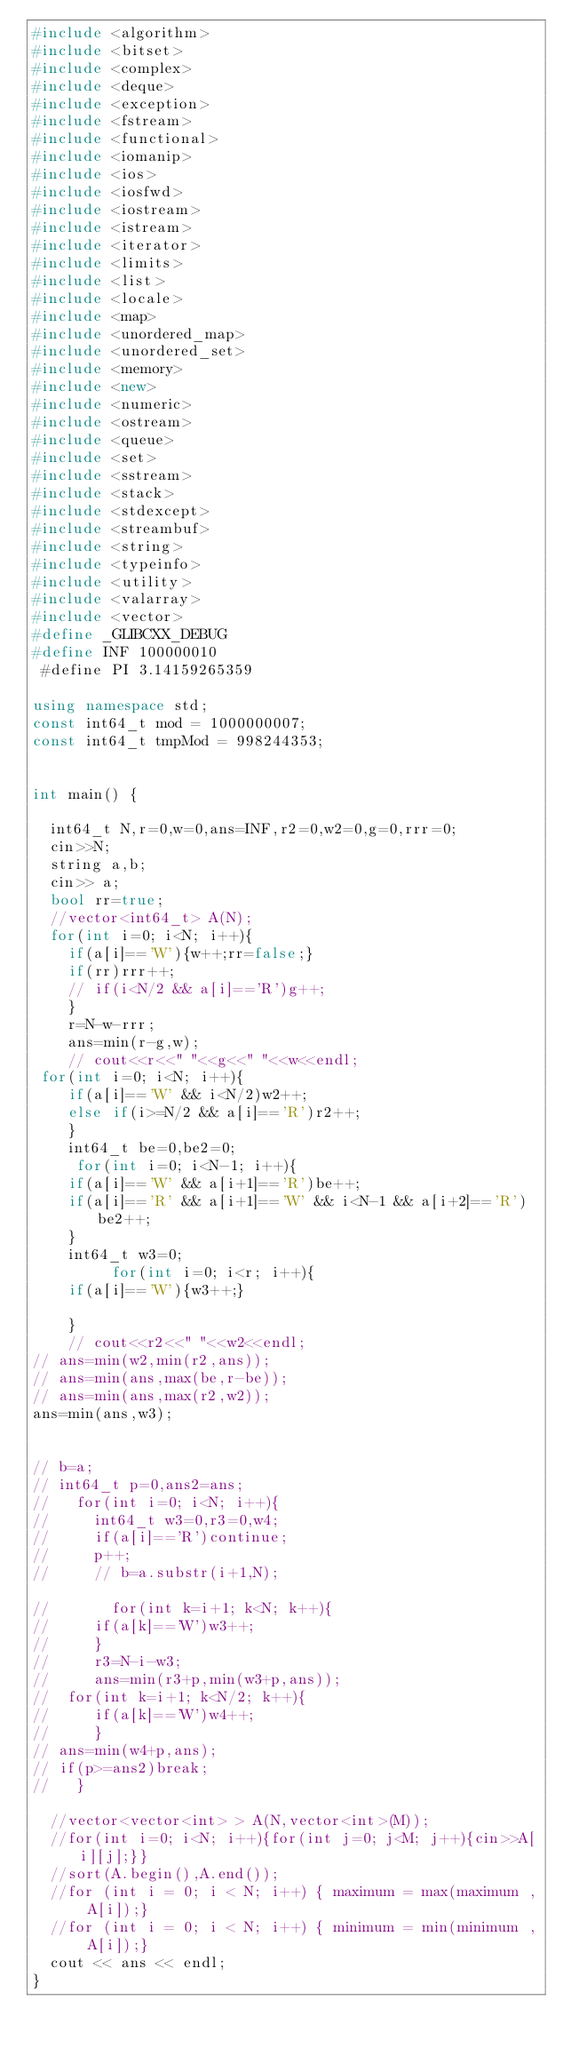Convert code to text. <code><loc_0><loc_0><loc_500><loc_500><_C++_>#include <algorithm>
#include <bitset>
#include <complex>
#include <deque>
#include <exception>
#include <fstream>
#include <functional>
#include <iomanip>
#include <ios>
#include <iosfwd>
#include <iostream>
#include <istream>
#include <iterator>
#include <limits>
#include <list>
#include <locale>
#include <map>
#include <unordered_map>
#include <unordered_set>
#include <memory>
#include <new>
#include <numeric>
#include <ostream>
#include <queue>
#include <set>
#include <sstream>
#include <stack>
#include <stdexcept>
#include <streambuf>
#include <string>
#include <typeinfo>
#include <utility>
#include <valarray>
#include <vector>
#define _GLIBCXX_DEBUG
#define INF 100000010
 #define PI 3.14159265359

using namespace std;
const int64_t mod = 1000000007;
const int64_t tmpMod = 998244353;


int main() {
 
  int64_t N,r=0,w=0,ans=INF,r2=0,w2=0,g=0,rrr=0;
  cin>>N;
  string a,b;
  cin>> a;
  bool rr=true;
  //vector<int64_t> A(N);
  for(int i=0; i<N; i++){
    if(a[i]=='W'){w++;rr=false;}
    if(rr)rrr++;
    // if(i<N/2 && a[i]=='R')g++;
    }
    r=N-w-rrr;
    ans=min(r-g,w);
    // cout<<r<<" "<<g<<" "<<w<<endl;
 for(int i=0; i<N; i++){
    if(a[i]=='W' && i<N/2)w2++;
    else if(i>=N/2 && a[i]=='R')r2++;
    }
    int64_t be=0,be2=0;
     for(int i=0; i<N-1; i++){
    if(a[i]=='W' && a[i+1]=='R')be++;
    if(a[i]=='R' && a[i+1]=='W' && i<N-1 && a[i+2]=='R')be2++;
    }
    int64_t w3=0;
         for(int i=0; i<r; i++){
    if(a[i]=='W'){w3++;}
    
    }
    // cout<<r2<<" "<<w2<<endl;
// ans=min(w2,min(r2,ans));
// ans=min(ans,max(be,r-be));
// ans=min(ans,max(r2,w2));
ans=min(ans,w3);


// b=a;
// int64_t p=0,ans2=ans;
//   for(int i=0; i<N; i++){
//     int64_t w3=0,r3=0,w4;
//     if(a[i]=='R')continue;
//     p++;
//     // b=a.substr(i+1,N);

//       for(int k=i+1; k<N; k++){
//     if(a[k]=='W')w3++;
//     }
//     r3=N-i-w3;
//     ans=min(r3+p,min(w3+p,ans));
//  for(int k=i+1; k<N/2; k++){
//     if(a[k]=='W')w4++;
//     }
// ans=min(w4+p,ans);
// if(p>=ans2)break;
//   }

  //vector<vector<int> > A(N,vector<int>(M));
  //for(int i=0; i<N; i++){for(int j=0; j<M; j++){cin>>A[i][j];}}
  //sort(A.begin(),A.end());
  //for (int i = 0; i < N; i++) { maximum = max(maximum , A[i]);}
  //for (int i = 0; i < N; i++) { minimum = min(minimum , A[i]);}
  cout << ans << endl;
}</code> 